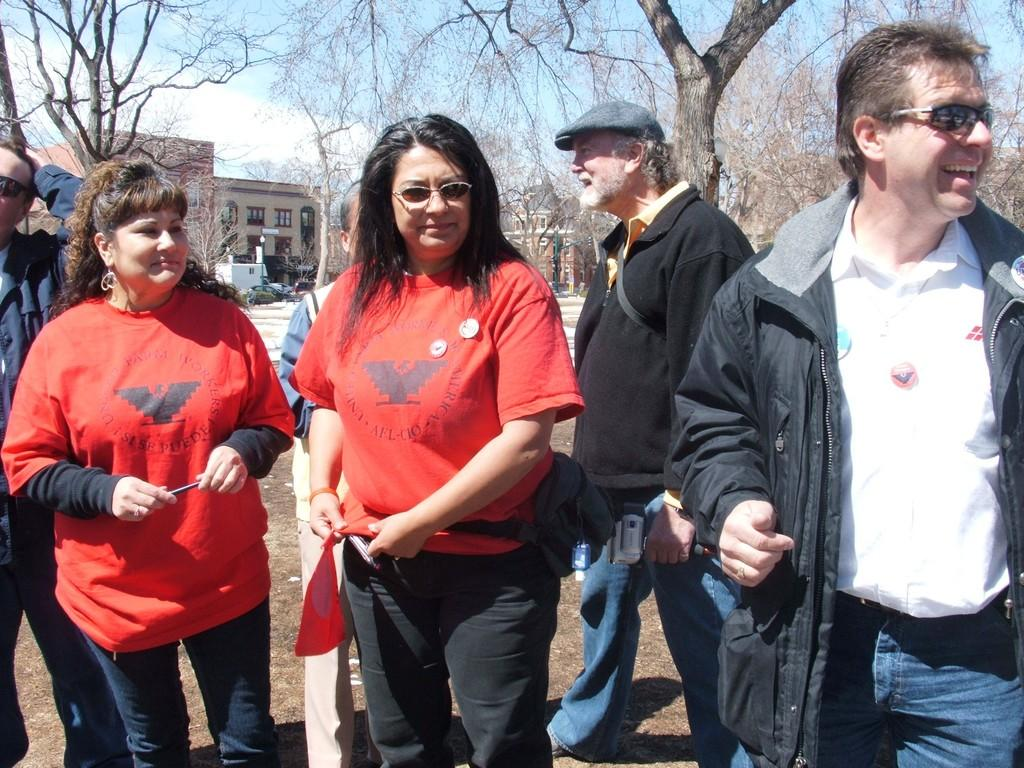Who or what can be seen in the front of the image? There are people in the front of the image. What can be seen in the background of the image? There are cars, buildings, and trees in the background of the image. What is visible at the top of the image? The sky is visible at the top of the image. What type of ink is being used to write on the buildings in the image? There is no indication in the image that any ink is being used to write on the buildings, as the image does not show any writing or drawing on the buildings. 